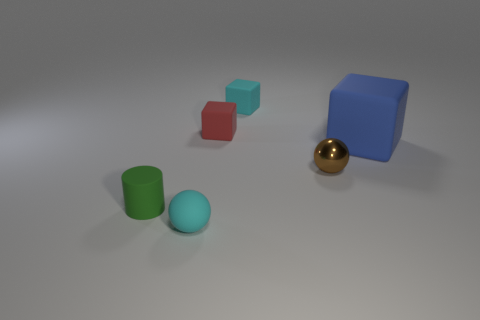Subtract all tiny cyan cubes. How many cubes are left? 2 Add 3 red blocks. How many objects exist? 9 Subtract all brown blocks. Subtract all yellow cylinders. How many blocks are left? 3 Subtract all cylinders. How many objects are left? 5 Add 3 metallic spheres. How many metallic spheres exist? 4 Subtract 0 gray cylinders. How many objects are left? 6 Subtract all small rubber things. Subtract all cyan objects. How many objects are left? 0 Add 2 tiny brown objects. How many tiny brown objects are left? 3 